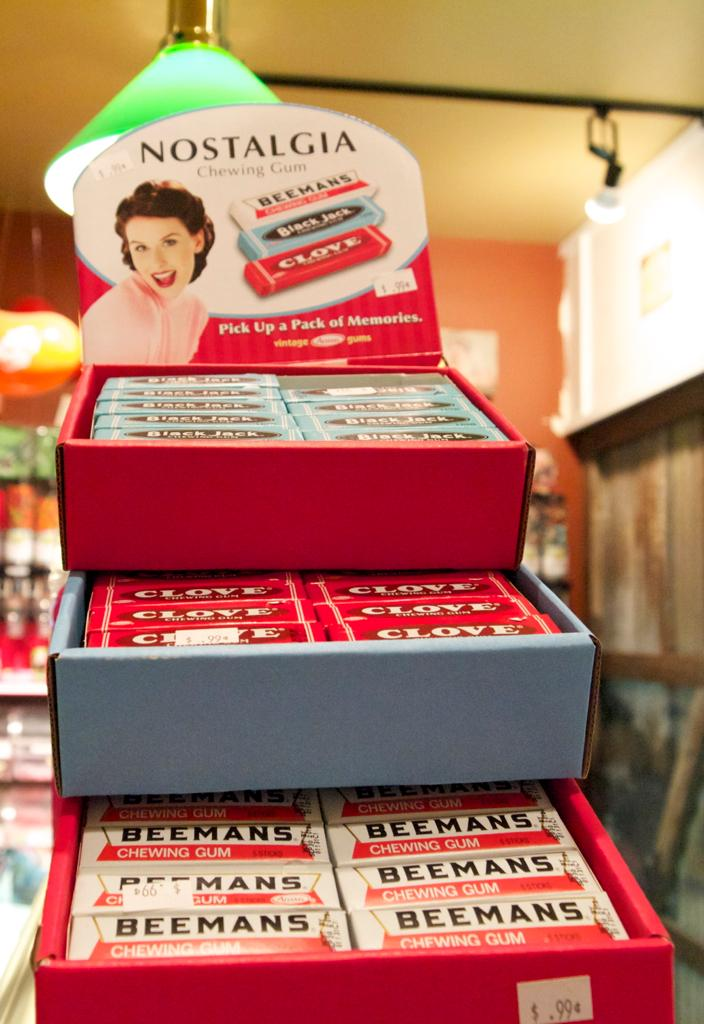<image>
Present a compact description of the photo's key features. Various gum flavors from Nostalgia priced 99 cents. 